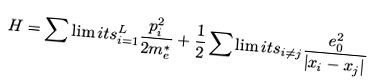<formula> <loc_0><loc_0><loc_500><loc_500>H = \sum \lim i t s _ { i = 1 } ^ { L } { \frac { p _ { i } ^ { 2 } } { 2 m _ { e } ^ { * } } + \frac { 1 } { 2 } } \sum \lim i t s _ { i \ne j } { \frac { e _ { 0 } ^ { 2 } } { { \left | { x _ { i } - x _ { j } } \right | } } }</formula> 